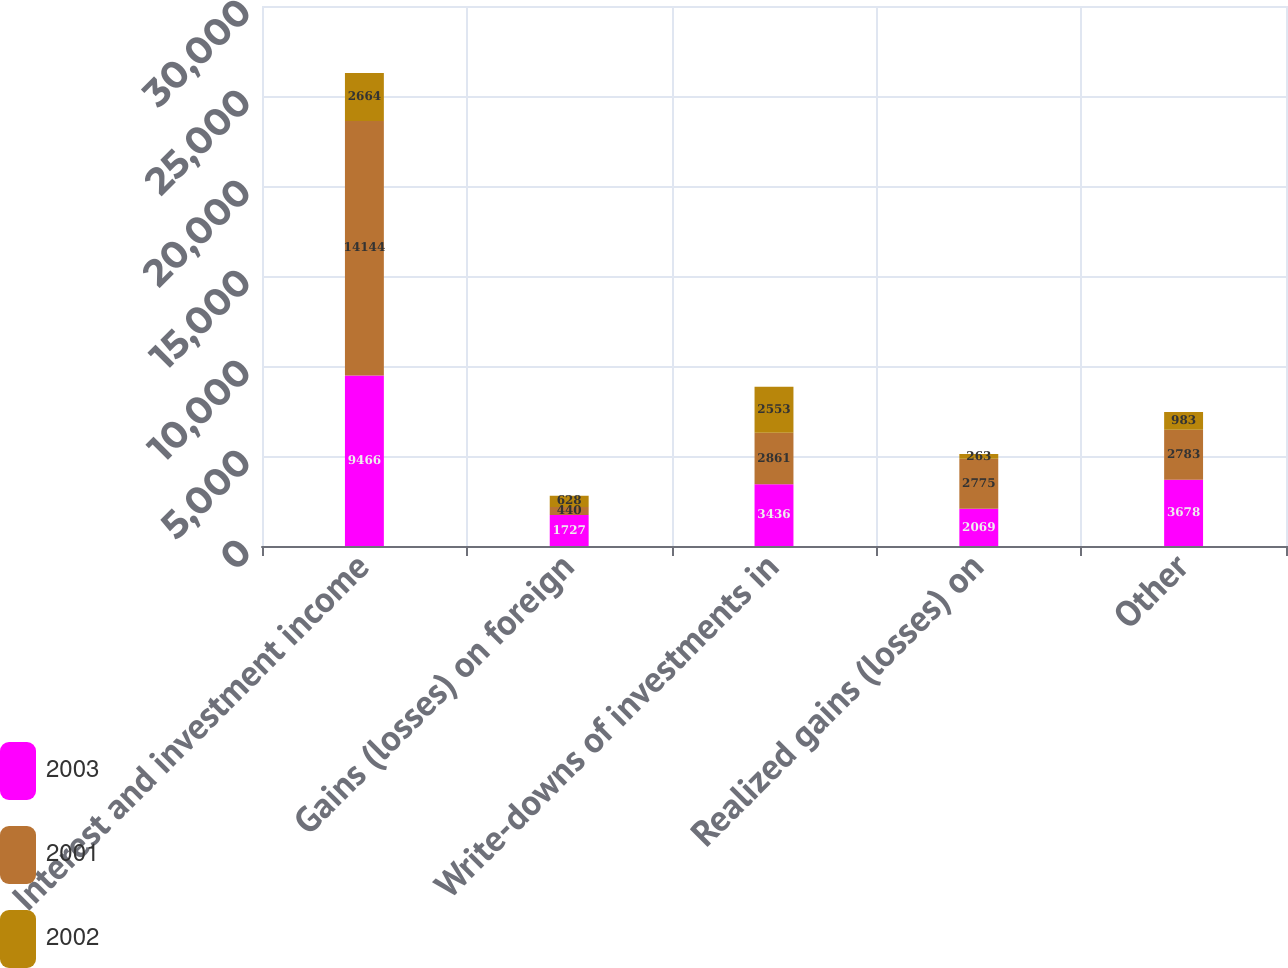Convert chart to OTSL. <chart><loc_0><loc_0><loc_500><loc_500><stacked_bar_chart><ecel><fcel>Interest and investment income<fcel>Gains (losses) on foreign<fcel>Write-downs of investments in<fcel>Realized gains (losses) on<fcel>Other<nl><fcel>2003<fcel>9466<fcel>1727<fcel>3436<fcel>2069<fcel>3678<nl><fcel>2001<fcel>14144<fcel>440<fcel>2861<fcel>2775<fcel>2783<nl><fcel>2002<fcel>2664<fcel>628<fcel>2553<fcel>263<fcel>983<nl></chart> 